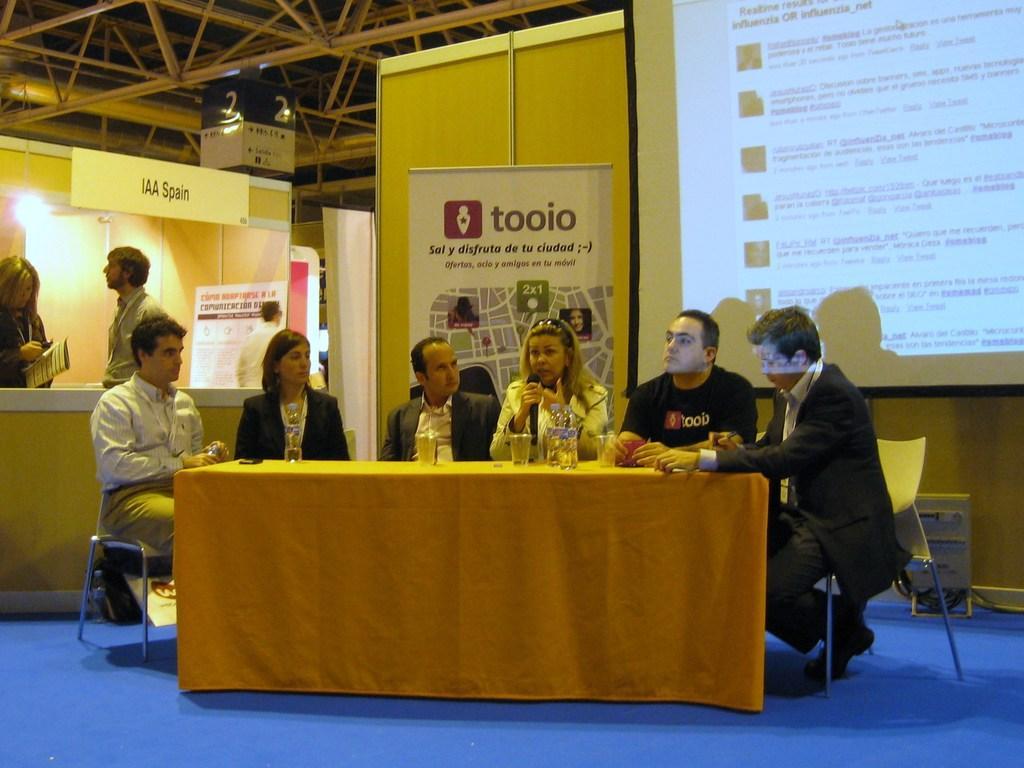Could you give a brief overview of what you see in this image? There are group of people sitting on the chairs. One of the woman is talking using a mike. This is a table covered with yellow cloth. At background I can see a banner and a foldable screen. And there are two people standing. 